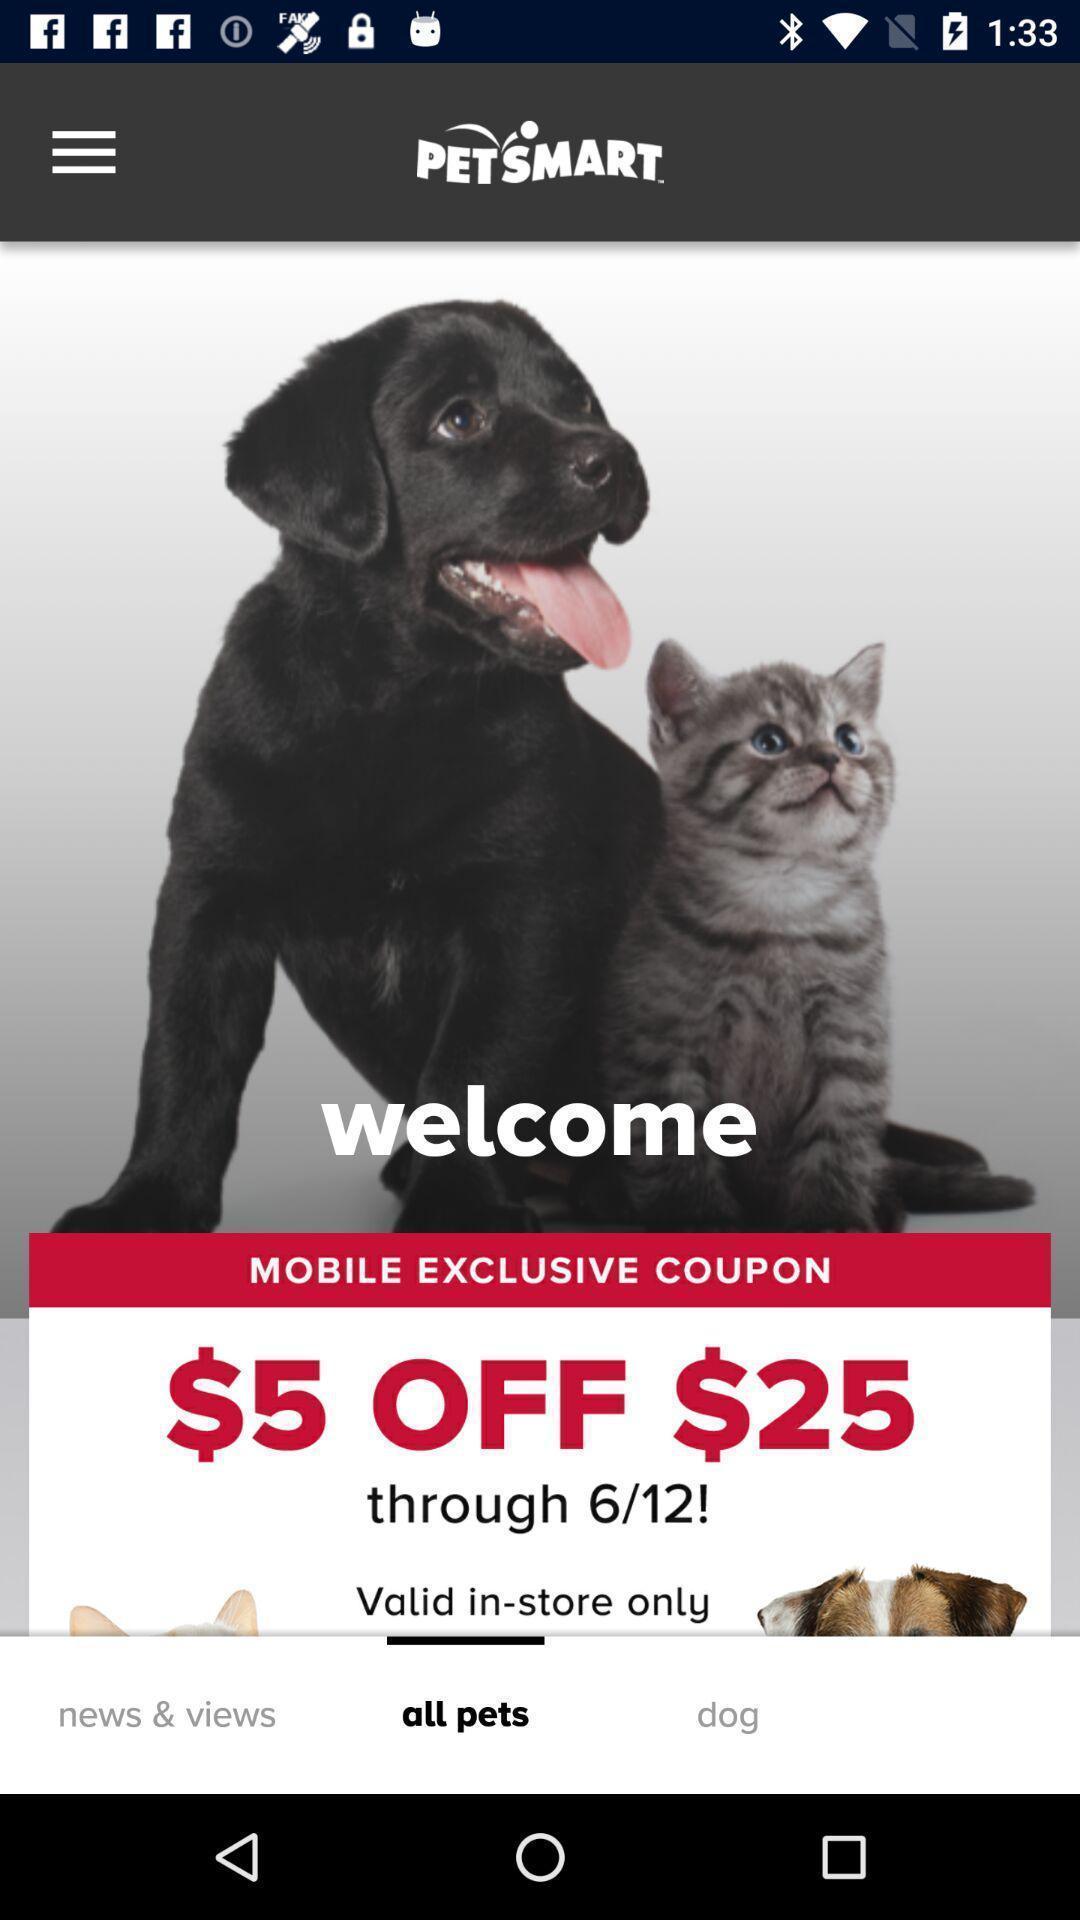Provide a detailed account of this screenshot. Welcome page of a pets app. 